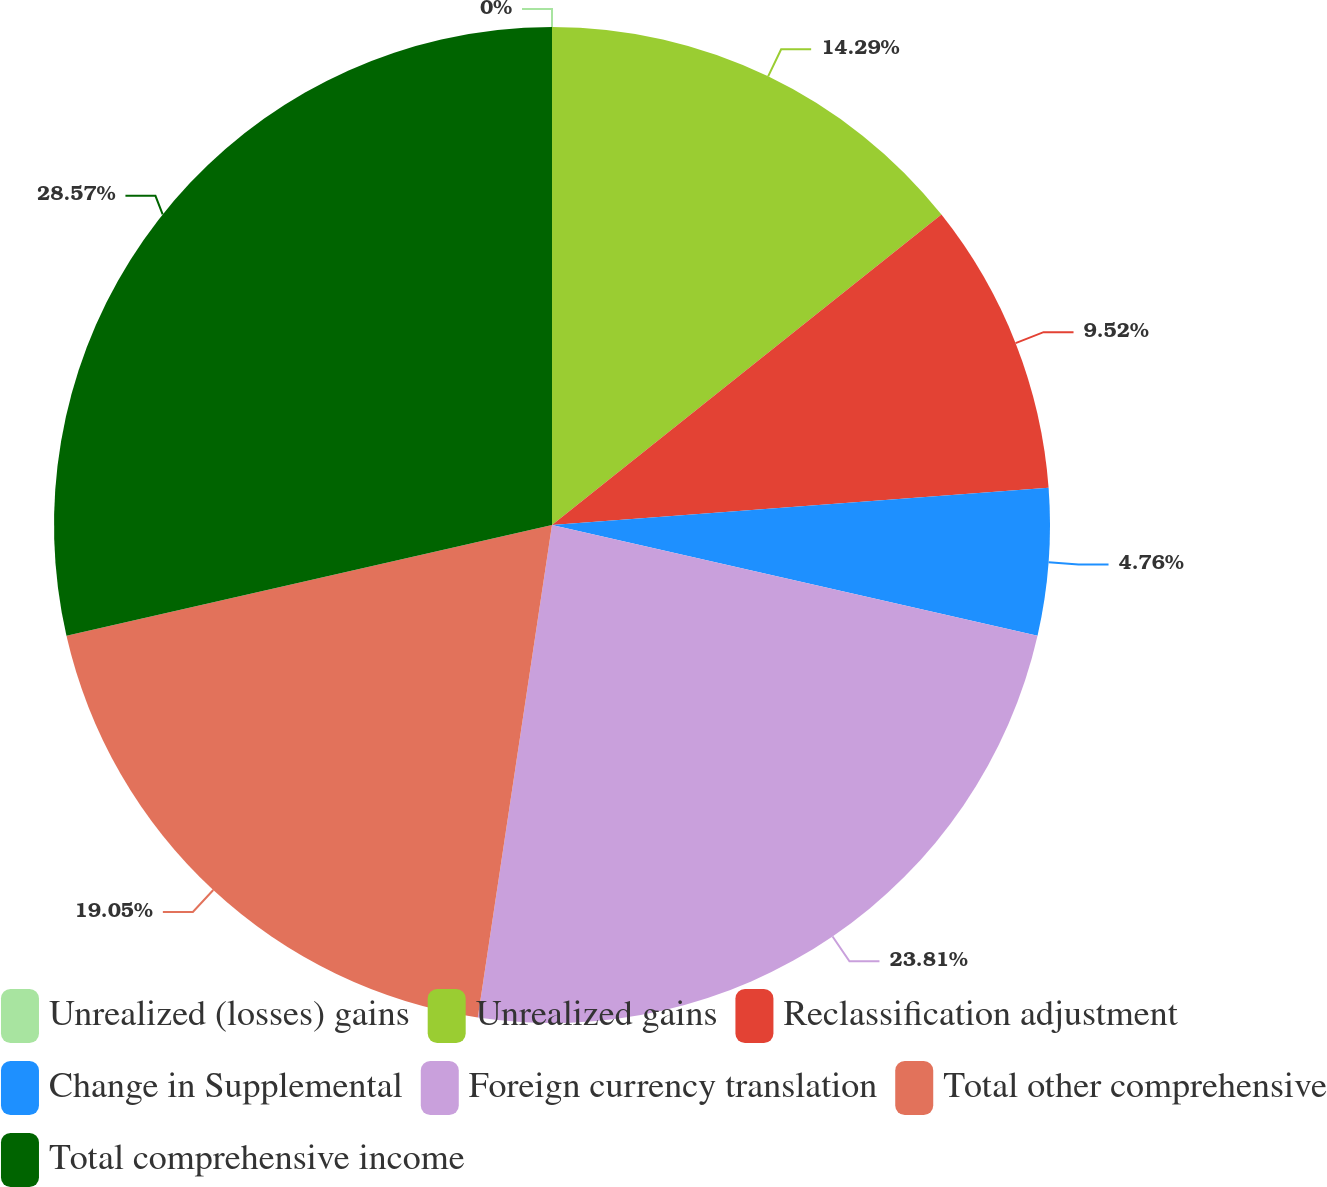Convert chart. <chart><loc_0><loc_0><loc_500><loc_500><pie_chart><fcel>Unrealized (losses) gains<fcel>Unrealized gains<fcel>Reclassification adjustment<fcel>Change in Supplemental<fcel>Foreign currency translation<fcel>Total other comprehensive<fcel>Total comprehensive income<nl><fcel>0.0%<fcel>14.29%<fcel>9.52%<fcel>4.76%<fcel>23.81%<fcel>19.05%<fcel>28.57%<nl></chart> 